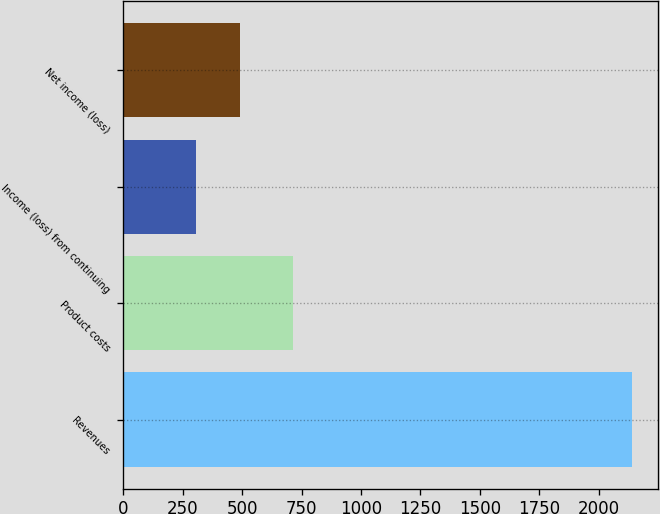<chart> <loc_0><loc_0><loc_500><loc_500><bar_chart><fcel>Revenues<fcel>Product costs<fcel>Income (loss) from continuing<fcel>Net income (loss)<nl><fcel>2141<fcel>716<fcel>308<fcel>491.3<nl></chart> 